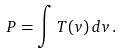Convert formula to latex. <formula><loc_0><loc_0><loc_500><loc_500>P = \int T ( v ) \, d v \, .</formula> 